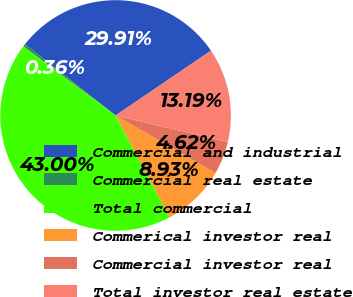Convert chart to OTSL. <chart><loc_0><loc_0><loc_500><loc_500><pie_chart><fcel>Commercial and industrial<fcel>Commercial real estate<fcel>Total commercial<fcel>Commerical investor real<fcel>Commercial investor real<fcel>Total investor real estate<nl><fcel>29.91%<fcel>0.36%<fcel>43.0%<fcel>8.93%<fcel>4.62%<fcel>13.19%<nl></chart> 